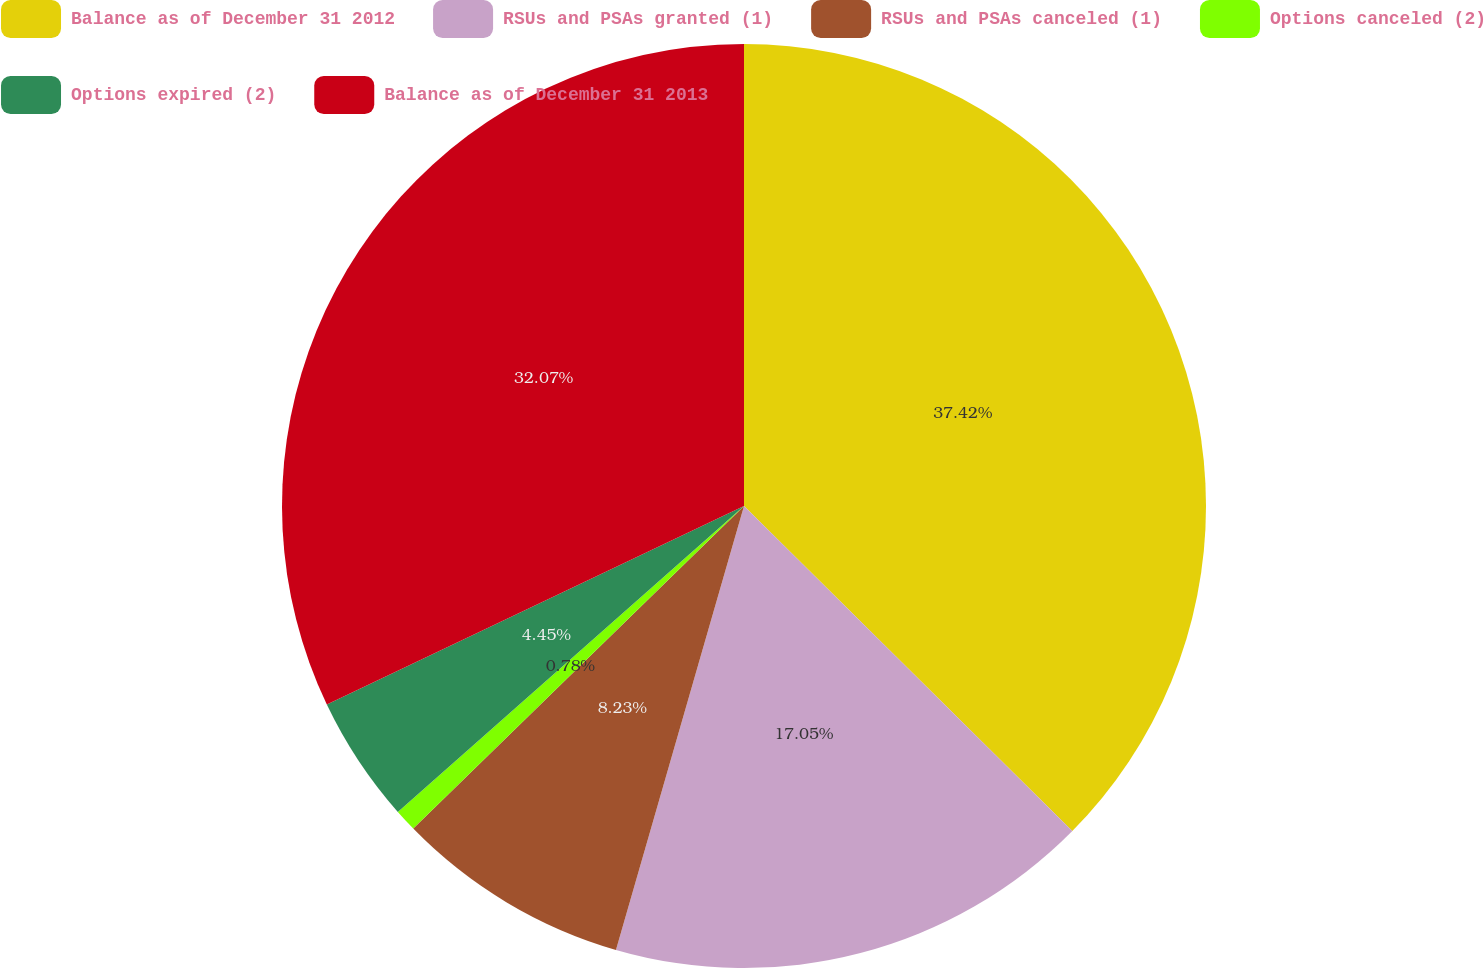<chart> <loc_0><loc_0><loc_500><loc_500><pie_chart><fcel>Balance as of December 31 2012<fcel>RSUs and PSAs granted (1)<fcel>RSUs and PSAs canceled (1)<fcel>Options canceled (2)<fcel>Options expired (2)<fcel>Balance as of December 31 2013<nl><fcel>37.42%<fcel>17.05%<fcel>8.23%<fcel>0.78%<fcel>4.45%<fcel>32.07%<nl></chart> 